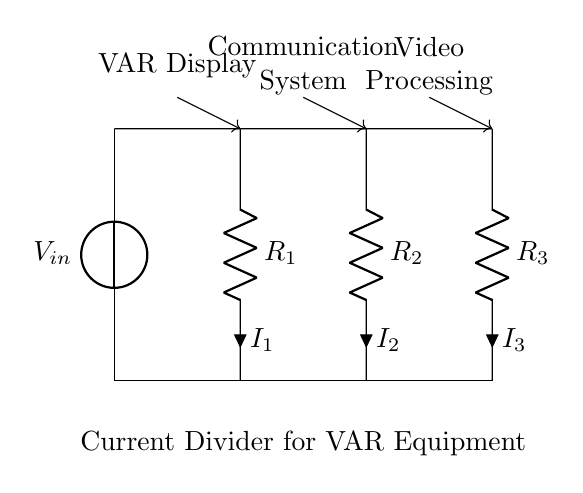What is the input voltage of the circuit? The input voltage, denoted as V_in, is represented by the voltage source at the top of the circuit.
Answer: V_in What does R_1 represent in the circuit? R_1 is a resistor in the circuit, and its designation indicates it is the first resistor connected to the current divider circuit for VAR equipment.
Answer: Resistor 1 Which component is responsible for the video processing? The component responsible for video processing is shown at the bottom of the circuit diagram, associated with the resistor R_3.
Answer: Video Processing What is the total number of resistors in this circuit? The circuit displays three resistors, R_1, R_2, and R_3, stacked in parallel for current division, which totals to three.
Answer: Three How does current divide in this circuit? In a current divider circuit, total input current is shared among the parallel resistors inversely proportional to their resistances, meaning each receives a different fraction based on their resistance values.
Answer: Inversely proportional to resistance Which component is the communication system powered by? The communication system is powered by the current flowing through resistor R_2, which receives its share of current from the division happening in the circuit.
Answer: R_2 What is the primary function of this current divider? The primary function of this current divider is to distribute the input current evenly across the components connected to it, such as the display, communication system, and video processing equipment, ensuring they operate correctly in VAR applications.
Answer: Distribute input current 